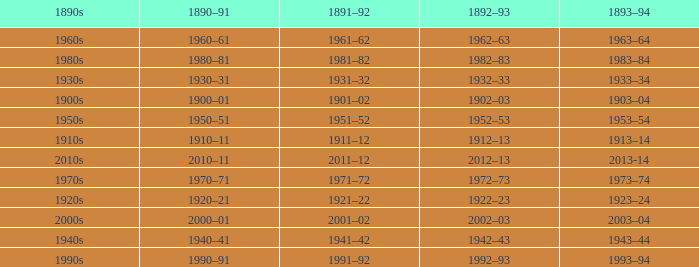What is the year from 1892-93 that has the 1890s to the 1940s? 1942–43. 